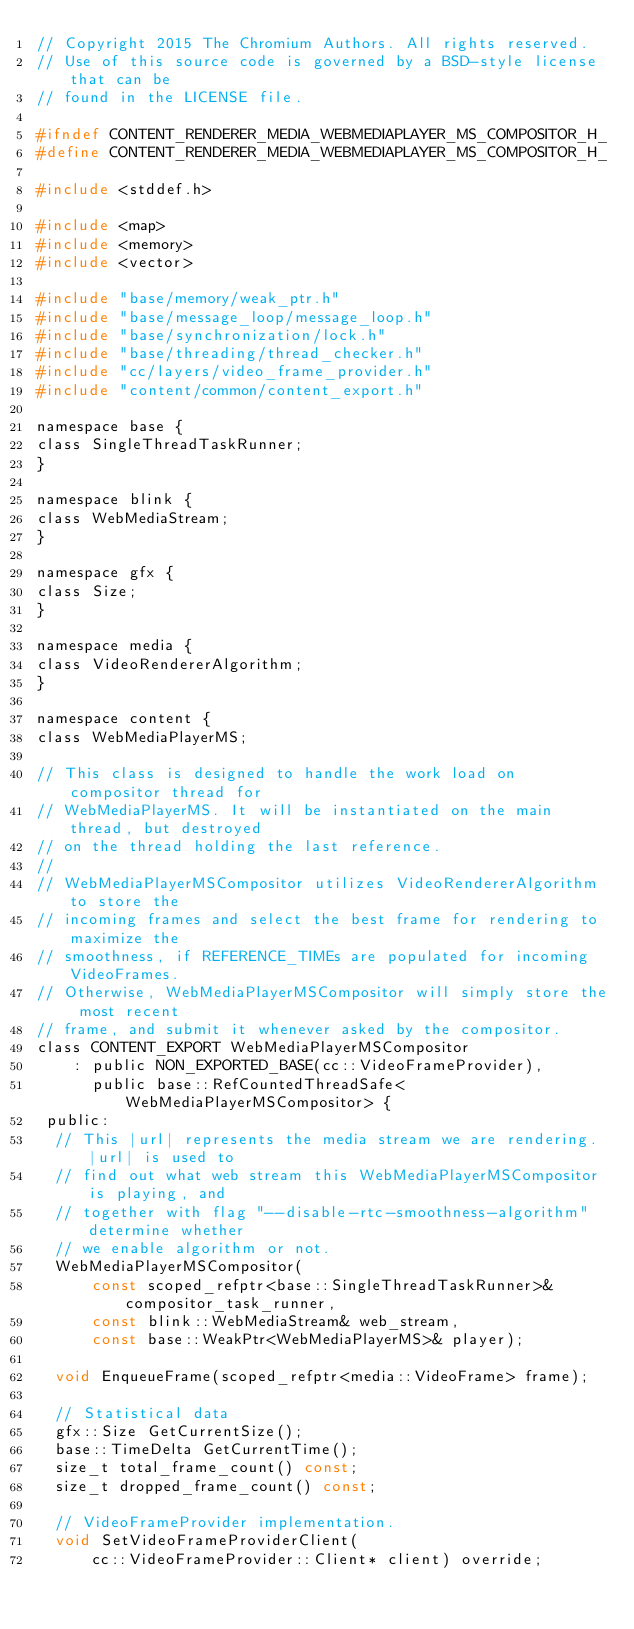Convert code to text. <code><loc_0><loc_0><loc_500><loc_500><_C_>// Copyright 2015 The Chromium Authors. All rights reserved.
// Use of this source code is governed by a BSD-style license that can be
// found in the LICENSE file.

#ifndef CONTENT_RENDERER_MEDIA_WEBMEDIAPLAYER_MS_COMPOSITOR_H_
#define CONTENT_RENDERER_MEDIA_WEBMEDIAPLAYER_MS_COMPOSITOR_H_

#include <stddef.h>

#include <map>
#include <memory>
#include <vector>

#include "base/memory/weak_ptr.h"
#include "base/message_loop/message_loop.h"
#include "base/synchronization/lock.h"
#include "base/threading/thread_checker.h"
#include "cc/layers/video_frame_provider.h"
#include "content/common/content_export.h"

namespace base {
class SingleThreadTaskRunner;
}

namespace blink {
class WebMediaStream;
}

namespace gfx {
class Size;
}

namespace media {
class VideoRendererAlgorithm;
}

namespace content {
class WebMediaPlayerMS;

// This class is designed to handle the work load on compositor thread for
// WebMediaPlayerMS. It will be instantiated on the main thread, but destroyed
// on the thread holding the last reference.
//
// WebMediaPlayerMSCompositor utilizes VideoRendererAlgorithm to store the
// incoming frames and select the best frame for rendering to maximize the
// smoothness, if REFERENCE_TIMEs are populated for incoming VideoFrames.
// Otherwise, WebMediaPlayerMSCompositor will simply store the most recent
// frame, and submit it whenever asked by the compositor.
class CONTENT_EXPORT WebMediaPlayerMSCompositor
    : public NON_EXPORTED_BASE(cc::VideoFrameProvider),
      public base::RefCountedThreadSafe<WebMediaPlayerMSCompositor> {
 public:
  // This |url| represents the media stream we are rendering. |url| is used to
  // find out what web stream this WebMediaPlayerMSCompositor is playing, and
  // together with flag "--disable-rtc-smoothness-algorithm" determine whether
  // we enable algorithm or not.
  WebMediaPlayerMSCompositor(
      const scoped_refptr<base::SingleThreadTaskRunner>& compositor_task_runner,
      const blink::WebMediaStream& web_stream,
      const base::WeakPtr<WebMediaPlayerMS>& player);

  void EnqueueFrame(scoped_refptr<media::VideoFrame> frame);

  // Statistical data
  gfx::Size GetCurrentSize();
  base::TimeDelta GetCurrentTime();
  size_t total_frame_count() const;
  size_t dropped_frame_count() const;

  // VideoFrameProvider implementation.
  void SetVideoFrameProviderClient(
      cc::VideoFrameProvider::Client* client) override;</code> 